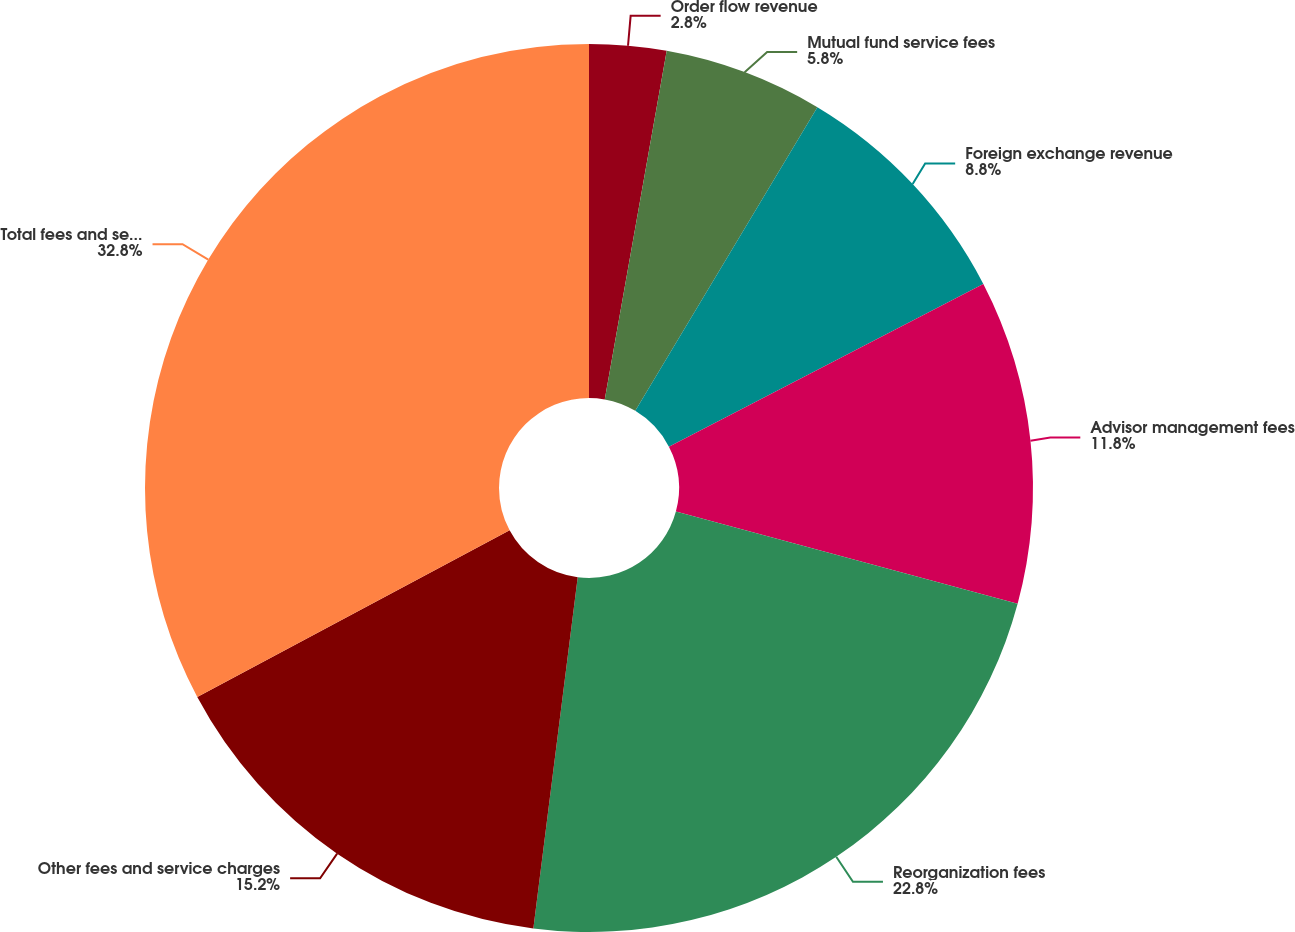Convert chart. <chart><loc_0><loc_0><loc_500><loc_500><pie_chart><fcel>Order flow revenue<fcel>Mutual fund service fees<fcel>Foreign exchange revenue<fcel>Advisor management fees<fcel>Reorganization fees<fcel>Other fees and service charges<fcel>Total fees and service charges<nl><fcel>2.8%<fcel>5.8%<fcel>8.8%<fcel>11.8%<fcel>22.8%<fcel>15.2%<fcel>32.8%<nl></chart> 